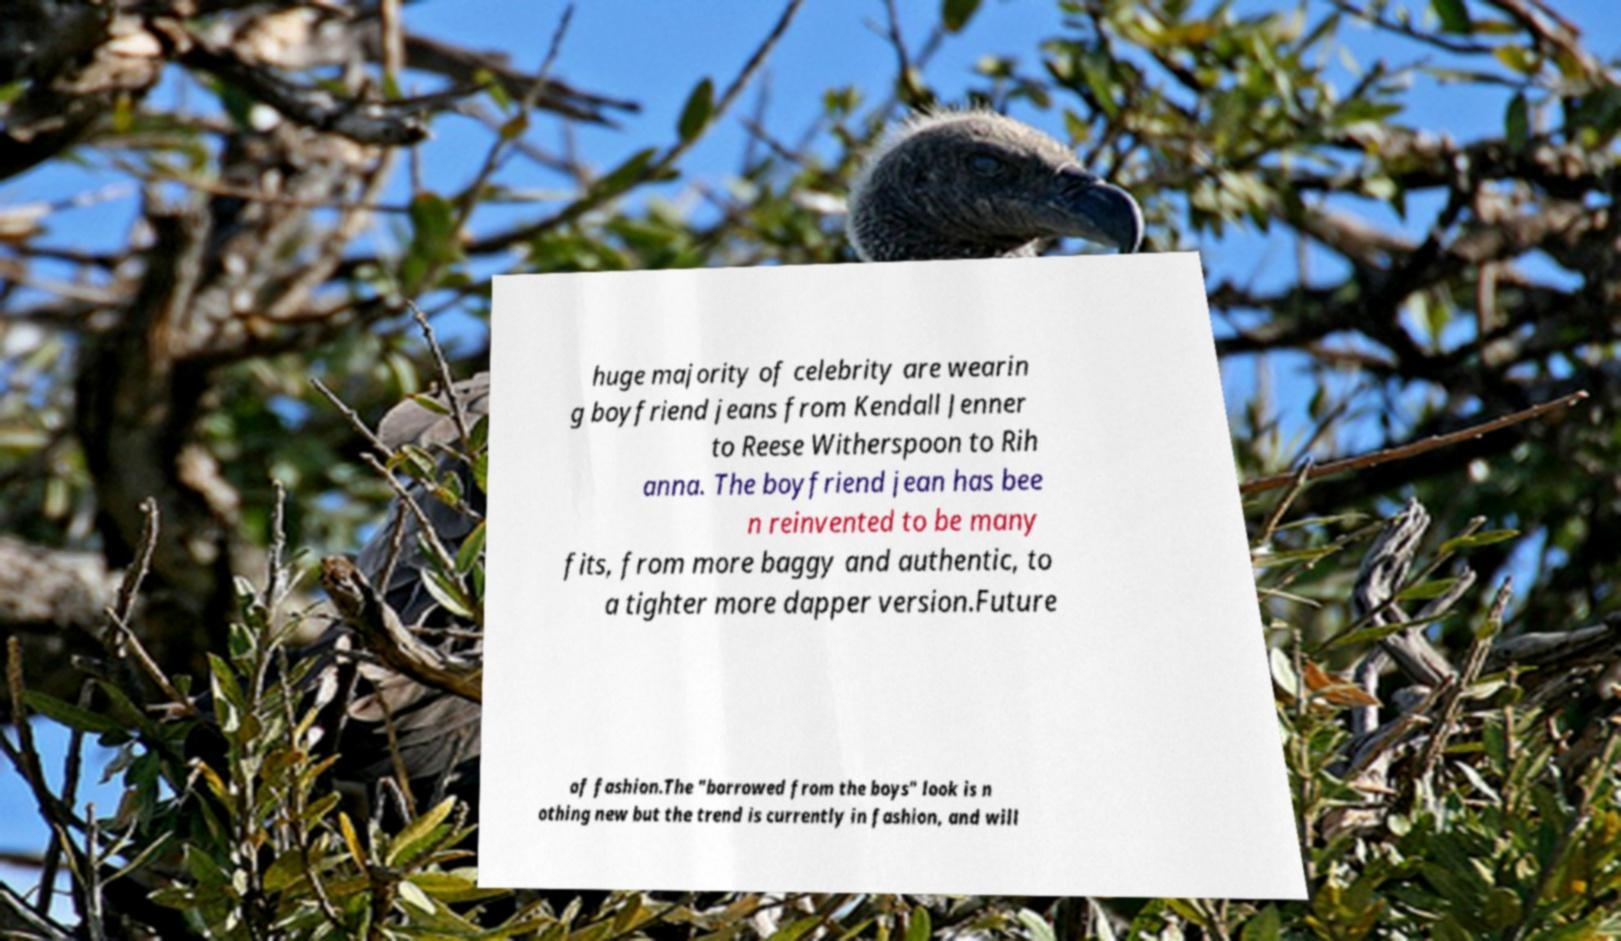I need the written content from this picture converted into text. Can you do that? huge majority of celebrity are wearin g boyfriend jeans from Kendall Jenner to Reese Witherspoon to Rih anna. The boyfriend jean has bee n reinvented to be many fits, from more baggy and authentic, to a tighter more dapper version.Future of fashion.The "borrowed from the boys" look is n othing new but the trend is currently in fashion, and will 